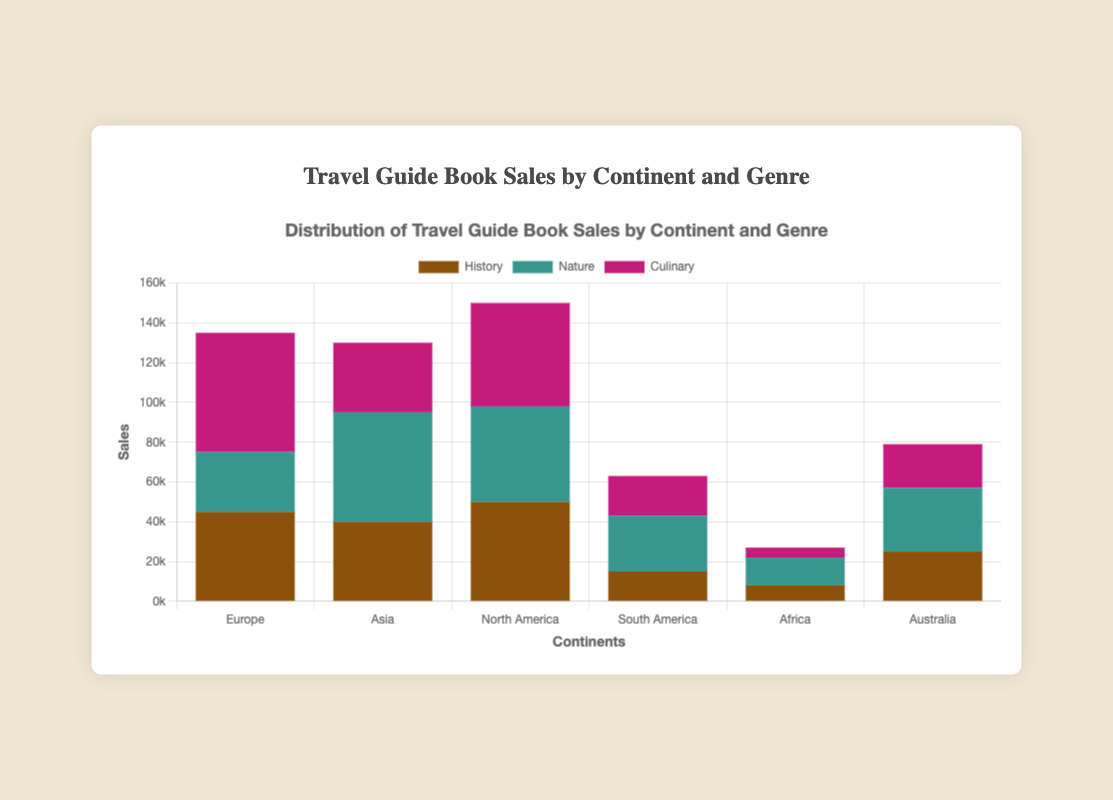Which continent has the highest sales of travel guide books across all genres? Summing the sales for each continent and comparing them shows that Europe has 135,000 (45000+30000+60000), Asia has 125,000 (40000+55000+35000), North America 150,000 (50000+48000+52000), South America 63,000 (15000+28000+20000), Africa 27,000 (8000+14000+5000), and Australia 79,000 (25000+32000+22000). North America has the highest total sales.
Answer: North America Which genre has the highest sales in Europe? In Europe, Culinary has the highest sales with 60,000 compared to History’s 45,000 and Nature’s 30,000.
Answer: Culinary Which genre contributes the least to travel guide book sales in Africa? Comparing sales in Africa, Culinary has the least with 5,000 compared to History’s 8,000 and Nature’s 14,000.
Answer: Culinary What is the difference in Nature genre sales between Asia and South America? Nature sales in Asia are 55,000, while in South America they are 28,000. Subtracting the two, 55,000 - 28,000, the difference is 27,000.
Answer: 27,000 What is the average sales for the Culinary genre across all continents? Summing the Culinary sales across all continents, we have 60,000 (Europe) + 35,000 (Asia) + 52,000 (North America) + 20,000 (South America) + 5,000 (Africa) + 22,000 (Australia) = 194,000. Dividing this by the number of continents (6), the average is 194,000 / 6 = 32,333.33.
Answer: 32,333.33 Which continent has equal or close sales in the History and Nature genres? Examining the sales, North America has close sales in History (50,000) and Nature (48,000) with a difference of only 2,000.
Answer: North America Which genre has the highest combined sales across all continents? Summing sales for all genres across all continents, History has (45,000+40,000+50,000+15,000+8,000+25,000) = 183,000, Nature has (30,000+55,000+48,000+28,000+14,000+32,000) = 207,000, and Culinary has (60,000+35,000+52,000+20,000+5,000+22,000) = 194,000. Nature has the highest combined sales.
Answer: Nature How do the sales for History genre in Europe compare with those in North America? History sales in Europe are 45,000 and in North America are 50,000. Comparing these, North America has higher sales by 5,000.
Answer: North America What are the total sales for all genres in Australia? In Australia, History accounts for 25,000, Nature 32,000, and Culinary 22,000, summing these gives 25,000 + 32,000 + 22,000 = 79,000.
Answer: 79,000 By how much do the Culinary sales in Europe exceed those in Asia? Culinary sales in Europe are 60,000 and in Asia are 35,000. The difference is 60,000 - 35,000 = 25,000.
Answer: 25,000 